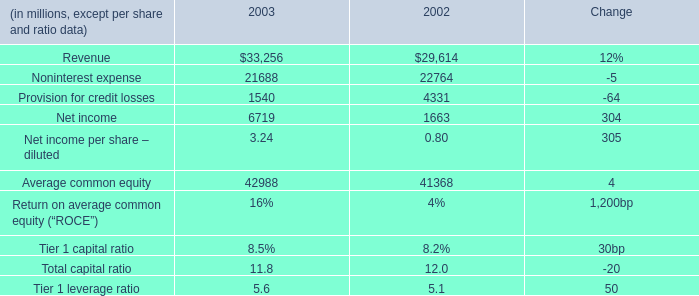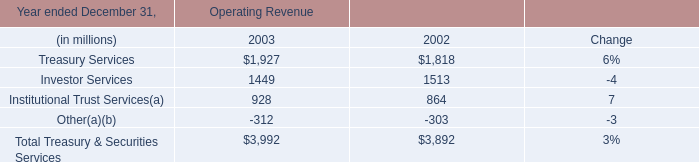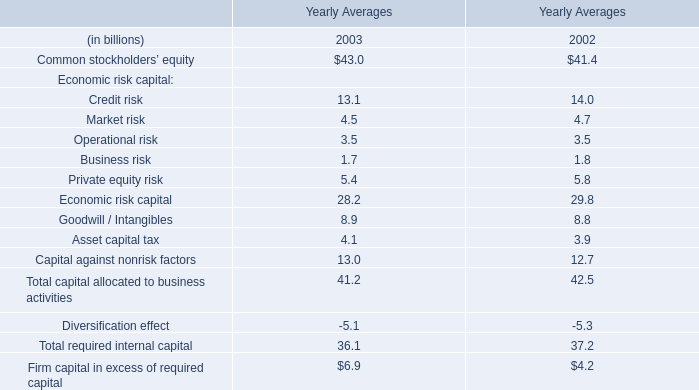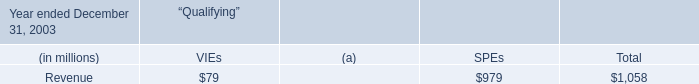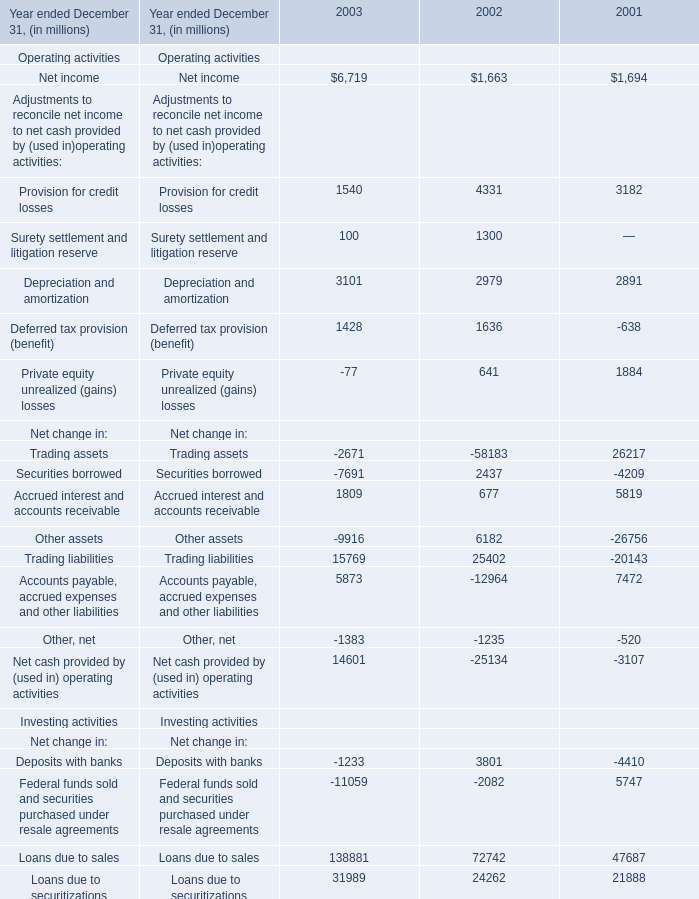What is the sum of Provision for credit losses of 2003, and Provision for credit losses of 2003 ? 
Computations: (1540.0 + 1540.0)
Answer: 3080.0. 